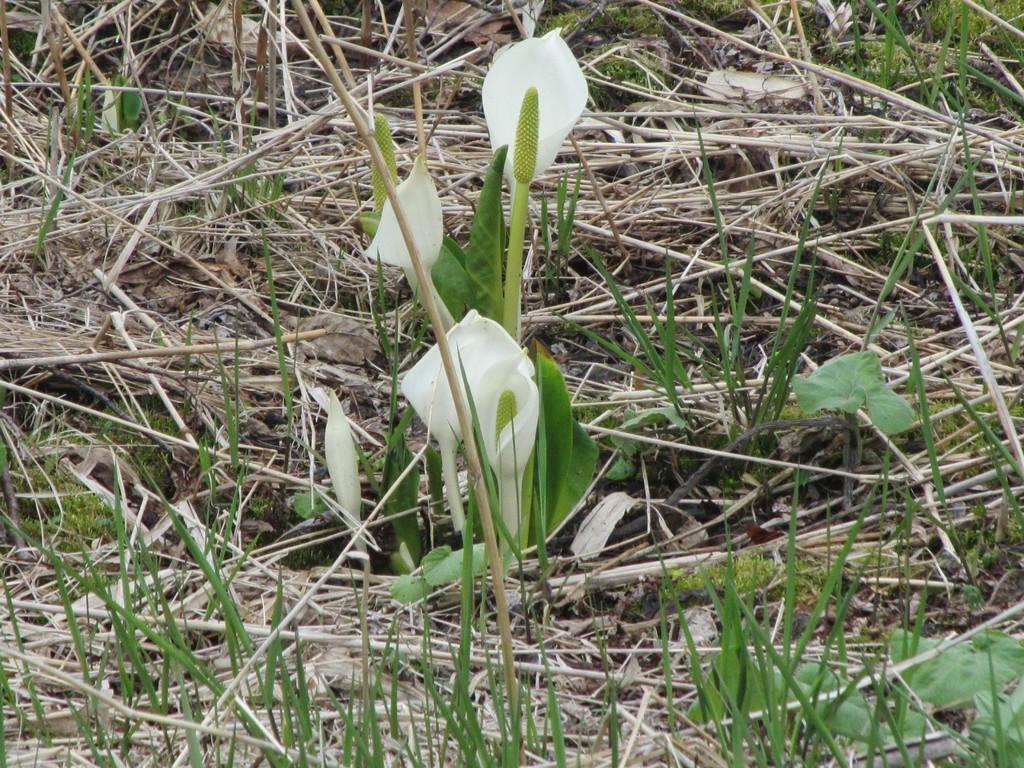How would you summarize this image in a sentence or two? In the image I can see some flowers to the stems and also I can see some dry grass. 